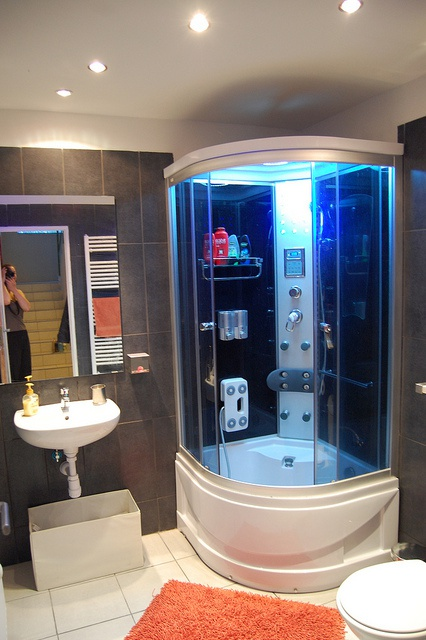Describe the objects in this image and their specific colors. I can see toilet in gray, white, darkgray, and tan tones, sink in gray, white, and tan tones, people in gray, black, brown, maroon, and darkgray tones, bottle in gray, brown, and violet tones, and bottle in gray, khaki, lightyellow, gold, and tan tones in this image. 